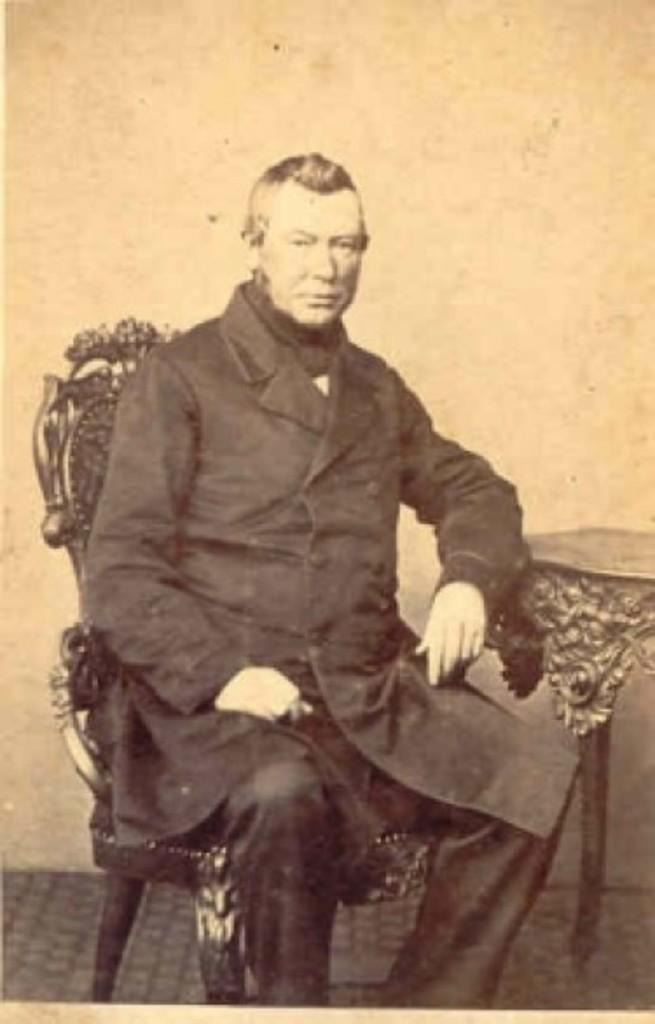What is the person in the image doing? The person is sitting on a chair in the image. What is located next to the chair? There is a table beside the chair. What is the person doing with their hand? The person's hand is on the table. What can be seen behind the person? There is a wall behind the person. What type of game is the person playing with the trucks and yarn in the image? There is no game, trucks, or yarn present in the image. 